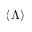<formula> <loc_0><loc_0><loc_500><loc_500>\langle \Lambda \rangle</formula> 